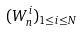<formula> <loc_0><loc_0><loc_500><loc_500>( W _ { n } ^ { i } ) _ { 1 \leq i \leq N }</formula> 